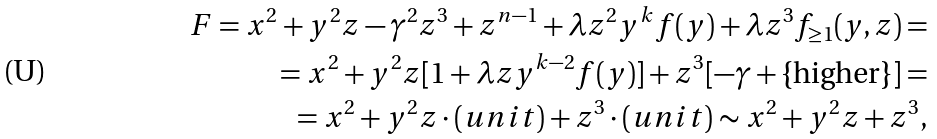<formula> <loc_0><loc_0><loc_500><loc_500>F = x ^ { 2 } + y ^ { 2 } z - \gamma ^ { 2 } z ^ { 3 } + z ^ { n - 1 } + \lambda z ^ { 2 } y ^ { k } f ( y ) + \lambda z ^ { 3 } f _ { \geq 1 } ( y , z ) = \\ = x ^ { 2 } + y ^ { 2 } z [ 1 + \lambda z y ^ { k - 2 } f ( y ) ] + z ^ { 3 } [ - \gamma + \text {\{higher\}} ] = \\ = x ^ { 2 } + y ^ { 2 } z \cdot ( u n i t ) + z ^ { 3 } \cdot ( u n i t ) \sim x ^ { 2 } + y ^ { 2 } z + z ^ { 3 } ,</formula> 